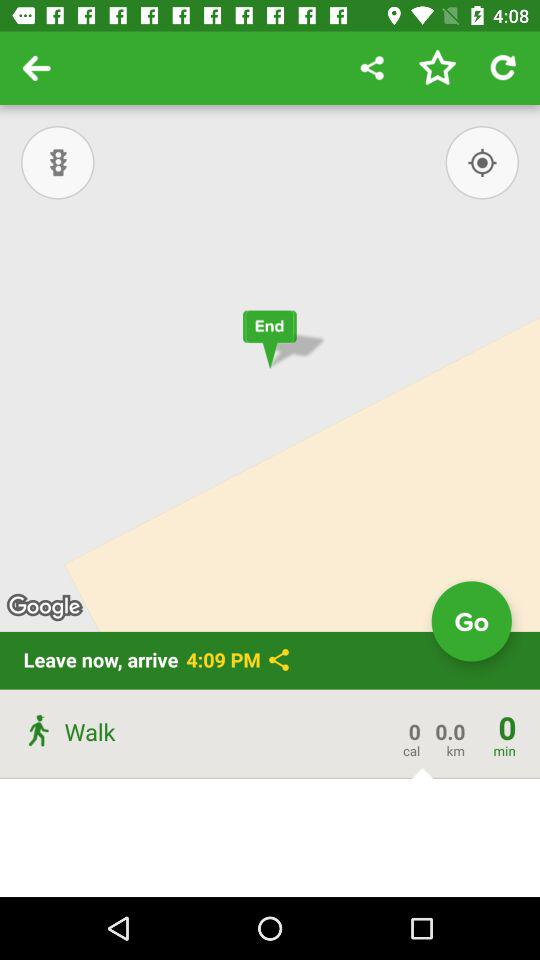What is the estimated arrival time? The estimated arrival time is 4:09 p.m. 